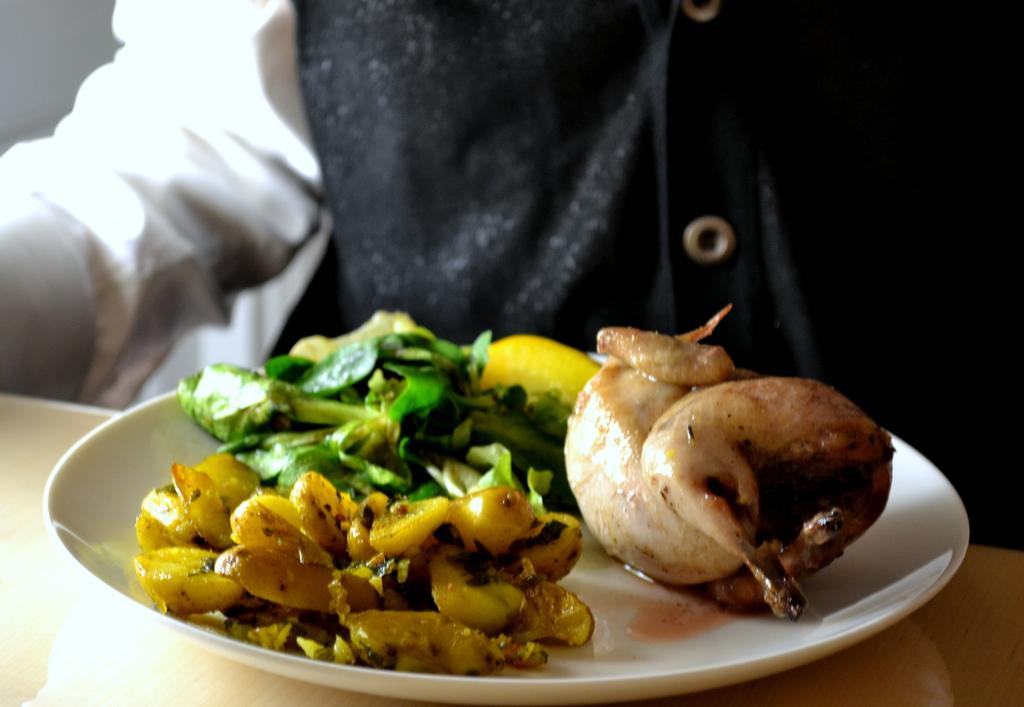What is present in the image? There is a person in the image. What is the person holding in the image? The person is holding an object. What is on the object that the person is holding? The object has a plate on it. What is placed in the plate? There are eatables placed in the plate. What type of texture can be seen on the prison walls in the image? There is no prison or prison walls present in the image. How many stitches are visible on the person's clothing in the image? The image does not provide enough detail to determine the number of stitches on the person's clothing. 